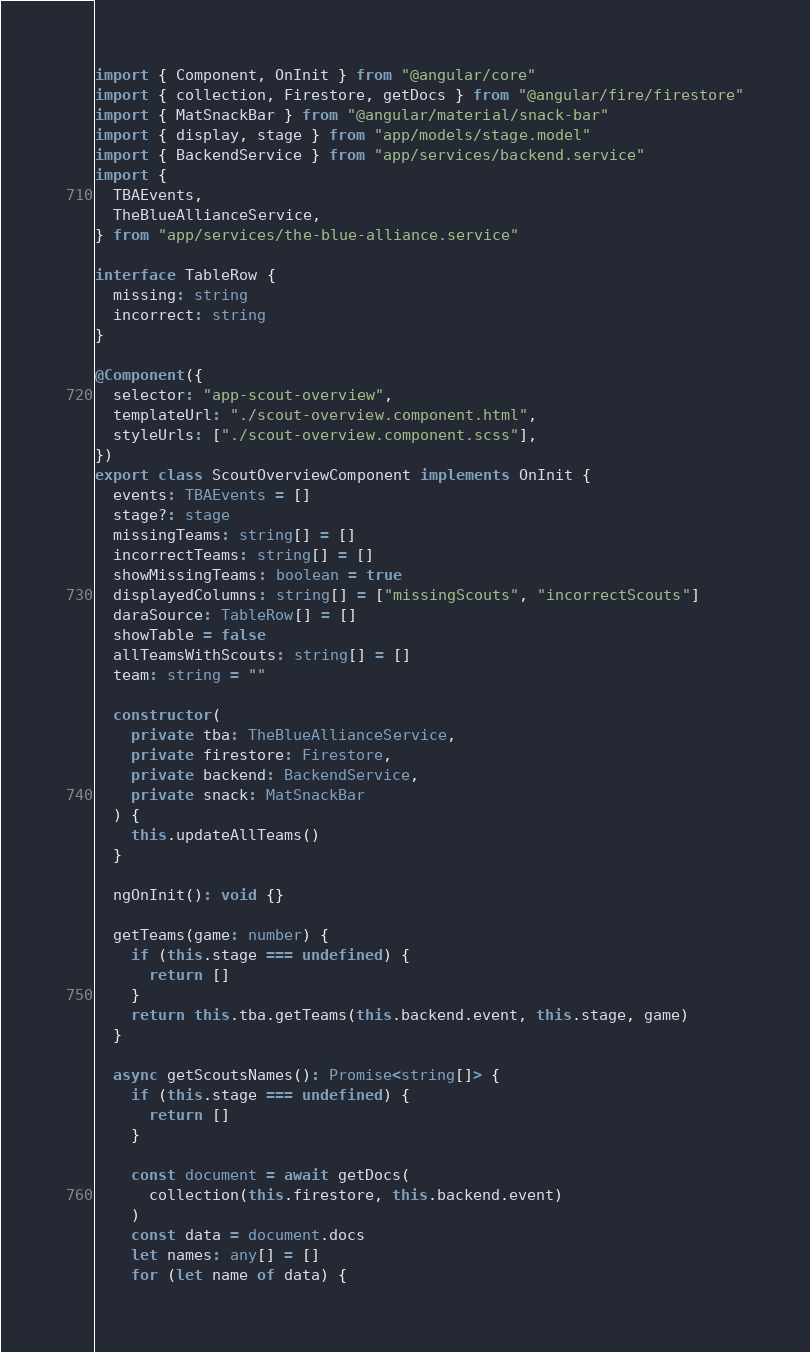Convert code to text. <code><loc_0><loc_0><loc_500><loc_500><_TypeScript_>import { Component, OnInit } from "@angular/core"
import { collection, Firestore, getDocs } from "@angular/fire/firestore"
import { MatSnackBar } from "@angular/material/snack-bar"
import { display, stage } from "app/models/stage.model"
import { BackendService } from "app/services/backend.service"
import {
  TBAEvents,
  TheBlueAllianceService,
} from "app/services/the-blue-alliance.service"

interface TableRow {
  missing: string
  incorrect: string
}

@Component({
  selector: "app-scout-overview",
  templateUrl: "./scout-overview.component.html",
  styleUrls: ["./scout-overview.component.scss"],
})
export class ScoutOverviewComponent implements OnInit {
  events: TBAEvents = []
  stage?: stage
  missingTeams: string[] = []
  incorrectTeams: string[] = []
  showMissingTeams: boolean = true
  displayedColumns: string[] = ["missingScouts", "incorrectScouts"]
  daraSource: TableRow[] = []
  showTable = false
  allTeamsWithScouts: string[] = []
  team: string = ""

  constructor(
    private tba: TheBlueAllianceService,
    private firestore: Firestore,
    private backend: BackendService,
    private snack: MatSnackBar
  ) {
    this.updateAllTeams()
  }

  ngOnInit(): void {}

  getTeams(game: number) {
    if (this.stage === undefined) {
      return []
    }
    return this.tba.getTeams(this.backend.event, this.stage, game)
  }

  async getScoutsNames(): Promise<string[]> {
    if (this.stage === undefined) {
      return []
    }

    const document = await getDocs(
      collection(this.firestore, this.backend.event)
    )
    const data = document.docs
    let names: any[] = []
    for (let name of data) {</code> 